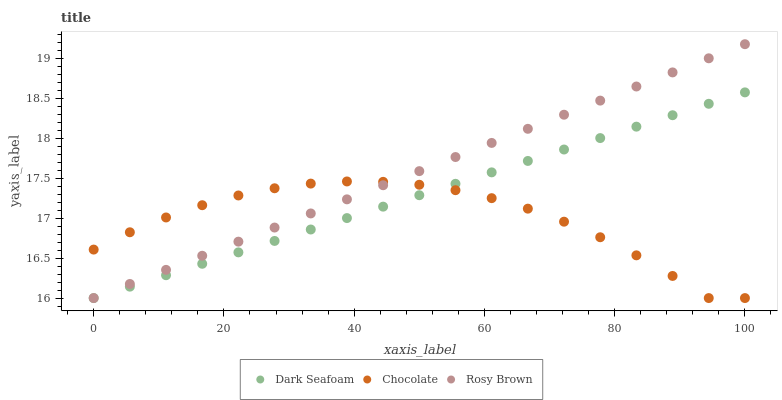Does Chocolate have the minimum area under the curve?
Answer yes or no. Yes. Does Rosy Brown have the maximum area under the curve?
Answer yes or no. Yes. Does Rosy Brown have the minimum area under the curve?
Answer yes or no. No. Does Chocolate have the maximum area under the curve?
Answer yes or no. No. Is Dark Seafoam the smoothest?
Answer yes or no. Yes. Is Chocolate the roughest?
Answer yes or no. Yes. Is Rosy Brown the smoothest?
Answer yes or no. No. Is Rosy Brown the roughest?
Answer yes or no. No. Does Dark Seafoam have the lowest value?
Answer yes or no. Yes. Does Rosy Brown have the highest value?
Answer yes or no. Yes. Does Chocolate have the highest value?
Answer yes or no. No. Does Dark Seafoam intersect Rosy Brown?
Answer yes or no. Yes. Is Dark Seafoam less than Rosy Brown?
Answer yes or no. No. Is Dark Seafoam greater than Rosy Brown?
Answer yes or no. No. 